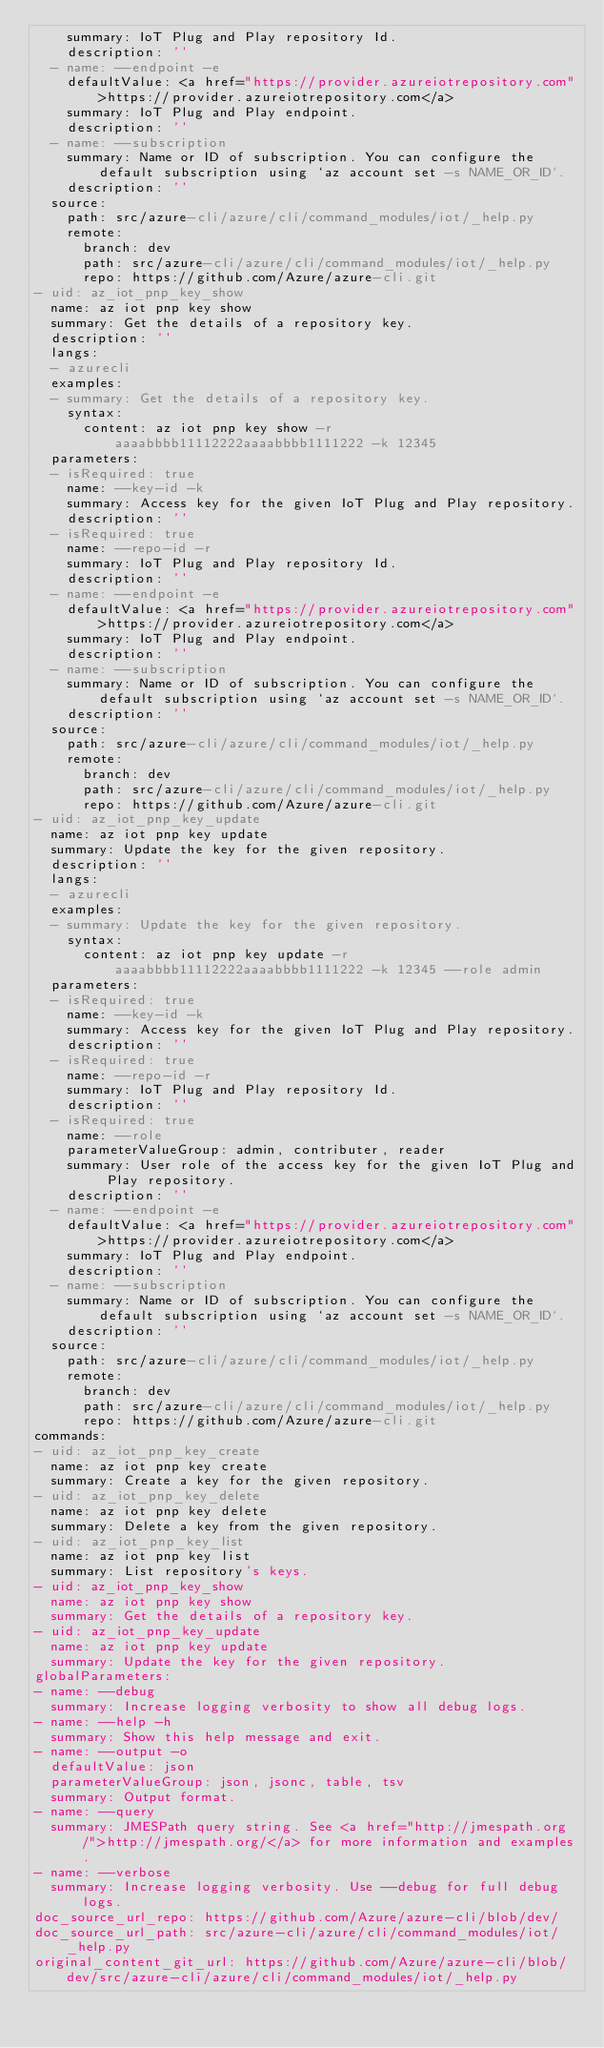<code> <loc_0><loc_0><loc_500><loc_500><_YAML_>    summary: IoT Plug and Play repository Id.
    description: ''
  - name: --endpoint -e
    defaultValue: <a href="https://provider.azureiotrepository.com">https://provider.azureiotrepository.com</a>
    summary: IoT Plug and Play endpoint.
    description: ''
  - name: --subscription
    summary: Name or ID of subscription. You can configure the default subscription using `az account set -s NAME_OR_ID`.
    description: ''
  source:
    path: src/azure-cli/azure/cli/command_modules/iot/_help.py
    remote:
      branch: dev
      path: src/azure-cli/azure/cli/command_modules/iot/_help.py
      repo: https://github.com/Azure/azure-cli.git
- uid: az_iot_pnp_key_show
  name: az iot pnp key show
  summary: Get the details of a repository key.
  description: ''
  langs:
  - azurecli
  examples:
  - summary: Get the details of a repository key.
    syntax:
      content: az iot pnp key show -r aaaabbbb11112222aaaabbbb1111222 -k 12345
  parameters:
  - isRequired: true
    name: --key-id -k
    summary: Access key for the given IoT Plug and Play repository.
    description: ''
  - isRequired: true
    name: --repo-id -r
    summary: IoT Plug and Play repository Id.
    description: ''
  - name: --endpoint -e
    defaultValue: <a href="https://provider.azureiotrepository.com">https://provider.azureiotrepository.com</a>
    summary: IoT Plug and Play endpoint.
    description: ''
  - name: --subscription
    summary: Name or ID of subscription. You can configure the default subscription using `az account set -s NAME_OR_ID`.
    description: ''
  source:
    path: src/azure-cli/azure/cli/command_modules/iot/_help.py
    remote:
      branch: dev
      path: src/azure-cli/azure/cli/command_modules/iot/_help.py
      repo: https://github.com/Azure/azure-cli.git
- uid: az_iot_pnp_key_update
  name: az iot pnp key update
  summary: Update the key for the given repository.
  description: ''
  langs:
  - azurecli
  examples:
  - summary: Update the key for the given repository.
    syntax:
      content: az iot pnp key update -r aaaabbbb11112222aaaabbbb1111222 -k 12345 --role admin
  parameters:
  - isRequired: true
    name: --key-id -k
    summary: Access key for the given IoT Plug and Play repository.
    description: ''
  - isRequired: true
    name: --repo-id -r
    summary: IoT Plug and Play repository Id.
    description: ''
  - isRequired: true
    name: --role
    parameterValueGroup: admin, contributer, reader
    summary: User role of the access key for the given IoT Plug and Play repository.
    description: ''
  - name: --endpoint -e
    defaultValue: <a href="https://provider.azureiotrepository.com">https://provider.azureiotrepository.com</a>
    summary: IoT Plug and Play endpoint.
    description: ''
  - name: --subscription
    summary: Name or ID of subscription. You can configure the default subscription using `az account set -s NAME_OR_ID`.
    description: ''
  source:
    path: src/azure-cli/azure/cli/command_modules/iot/_help.py
    remote:
      branch: dev
      path: src/azure-cli/azure/cli/command_modules/iot/_help.py
      repo: https://github.com/Azure/azure-cli.git
commands:
- uid: az_iot_pnp_key_create
  name: az iot pnp key create
  summary: Create a key for the given repository.
- uid: az_iot_pnp_key_delete
  name: az iot pnp key delete
  summary: Delete a key from the given repository.
- uid: az_iot_pnp_key_list
  name: az iot pnp key list
  summary: List repository's keys.
- uid: az_iot_pnp_key_show
  name: az iot pnp key show
  summary: Get the details of a repository key.
- uid: az_iot_pnp_key_update
  name: az iot pnp key update
  summary: Update the key for the given repository.
globalParameters:
- name: --debug
  summary: Increase logging verbosity to show all debug logs.
- name: --help -h
  summary: Show this help message and exit.
- name: --output -o
  defaultValue: json
  parameterValueGroup: json, jsonc, table, tsv
  summary: Output format.
- name: --query
  summary: JMESPath query string. See <a href="http://jmespath.org/">http://jmespath.org/</a> for more information and examples.
- name: --verbose
  summary: Increase logging verbosity. Use --debug for full debug logs.
doc_source_url_repo: https://github.com/Azure/azure-cli/blob/dev/
doc_source_url_path: src/azure-cli/azure/cli/command_modules/iot/_help.py
original_content_git_url: https://github.com/Azure/azure-cli/blob/dev/src/azure-cli/azure/cli/command_modules/iot/_help.py</code> 